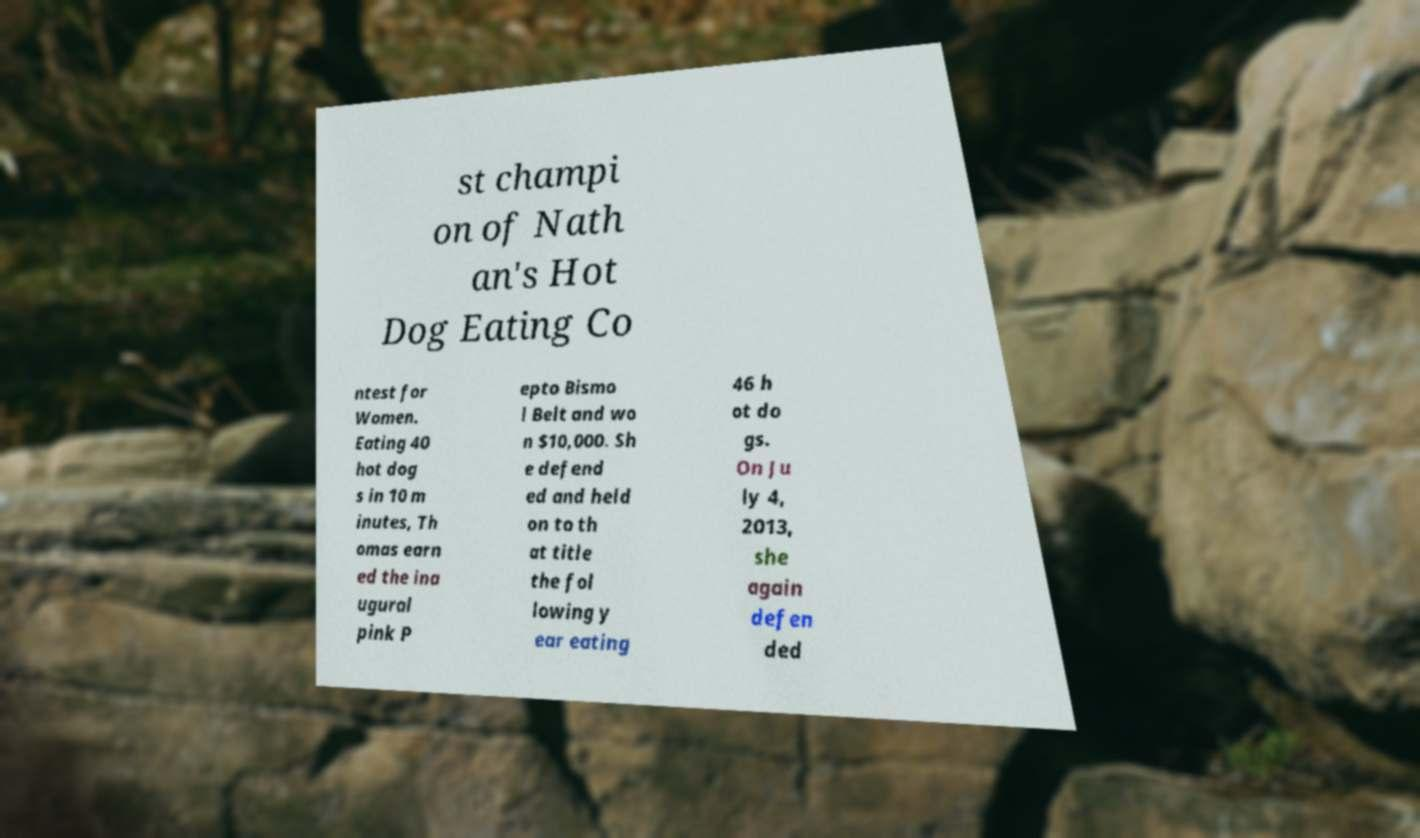Can you read and provide the text displayed in the image?This photo seems to have some interesting text. Can you extract and type it out for me? st champi on of Nath an's Hot Dog Eating Co ntest for Women. Eating 40 hot dog s in 10 m inutes, Th omas earn ed the ina ugural pink P epto Bismo l Belt and wo n $10,000. Sh e defend ed and held on to th at title the fol lowing y ear eating 46 h ot do gs. On Ju ly 4, 2013, she again defen ded 